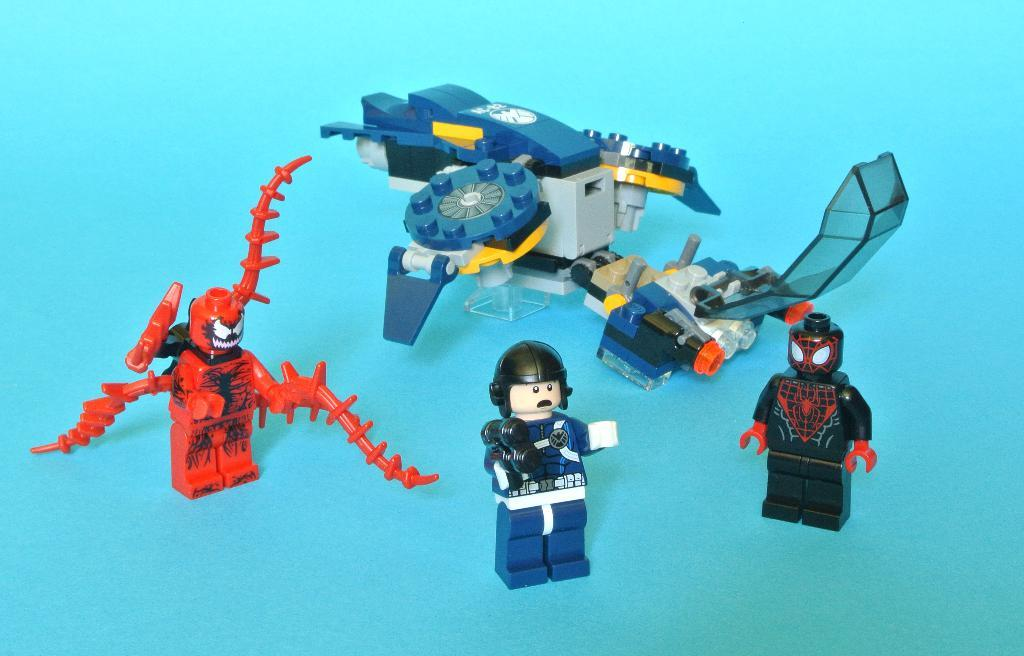What type of objects can be seen in the picture? There are miniatures in the picture. What color is the background of the picture? The background of the picture is blue. What type of throat medicine is visible in the picture? There is no throat medicine present in the picture; it features miniatures and a blue background. How much salt is sprinkled on the miniatures in the picture? There is no salt present in the picture, as it only contains miniatures and a blue background. 